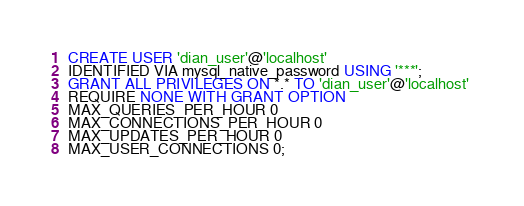Convert code to text. <code><loc_0><loc_0><loc_500><loc_500><_SQL_>CREATE USER 'dian_user'@'localhost' 
IDENTIFIED VIA mysql_native_password USING '***';
GRANT ALL PRIVILEGES ON *.* TO 'dian_user'@'localhost' 
REQUIRE NONE WITH GRANT OPTION 
MAX_QUERIES_PER_HOUR 0 
MAX_CONNECTIONS_PER_HOUR 0 
MAX_UPDATES_PER_HOUR 0 
MAX_USER_CONNECTIONS 0; </code> 